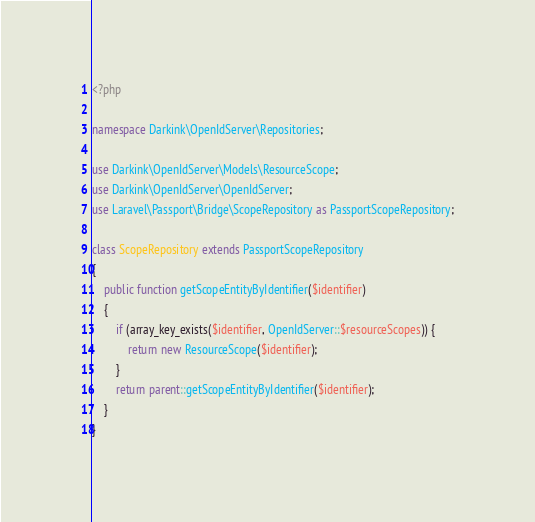<code> <loc_0><loc_0><loc_500><loc_500><_PHP_><?php

namespace Darkink\OpenIdServer\Repositories;

use Darkink\OpenIdServer\Models\ResourceScope;
use Darkink\OpenIdServer\OpenIdServer;
use Laravel\Passport\Bridge\ScopeRepository as PassportScopeRepository;

class ScopeRepository extends PassportScopeRepository
{
    public function getScopeEntityByIdentifier($identifier)
    {
        if (array_key_exists($identifier, OpenIdServer::$resourceScopes)) {
            return new ResourceScope($identifier);
        }
        return parent::getScopeEntityByIdentifier($identifier);
    }
}
</code> 